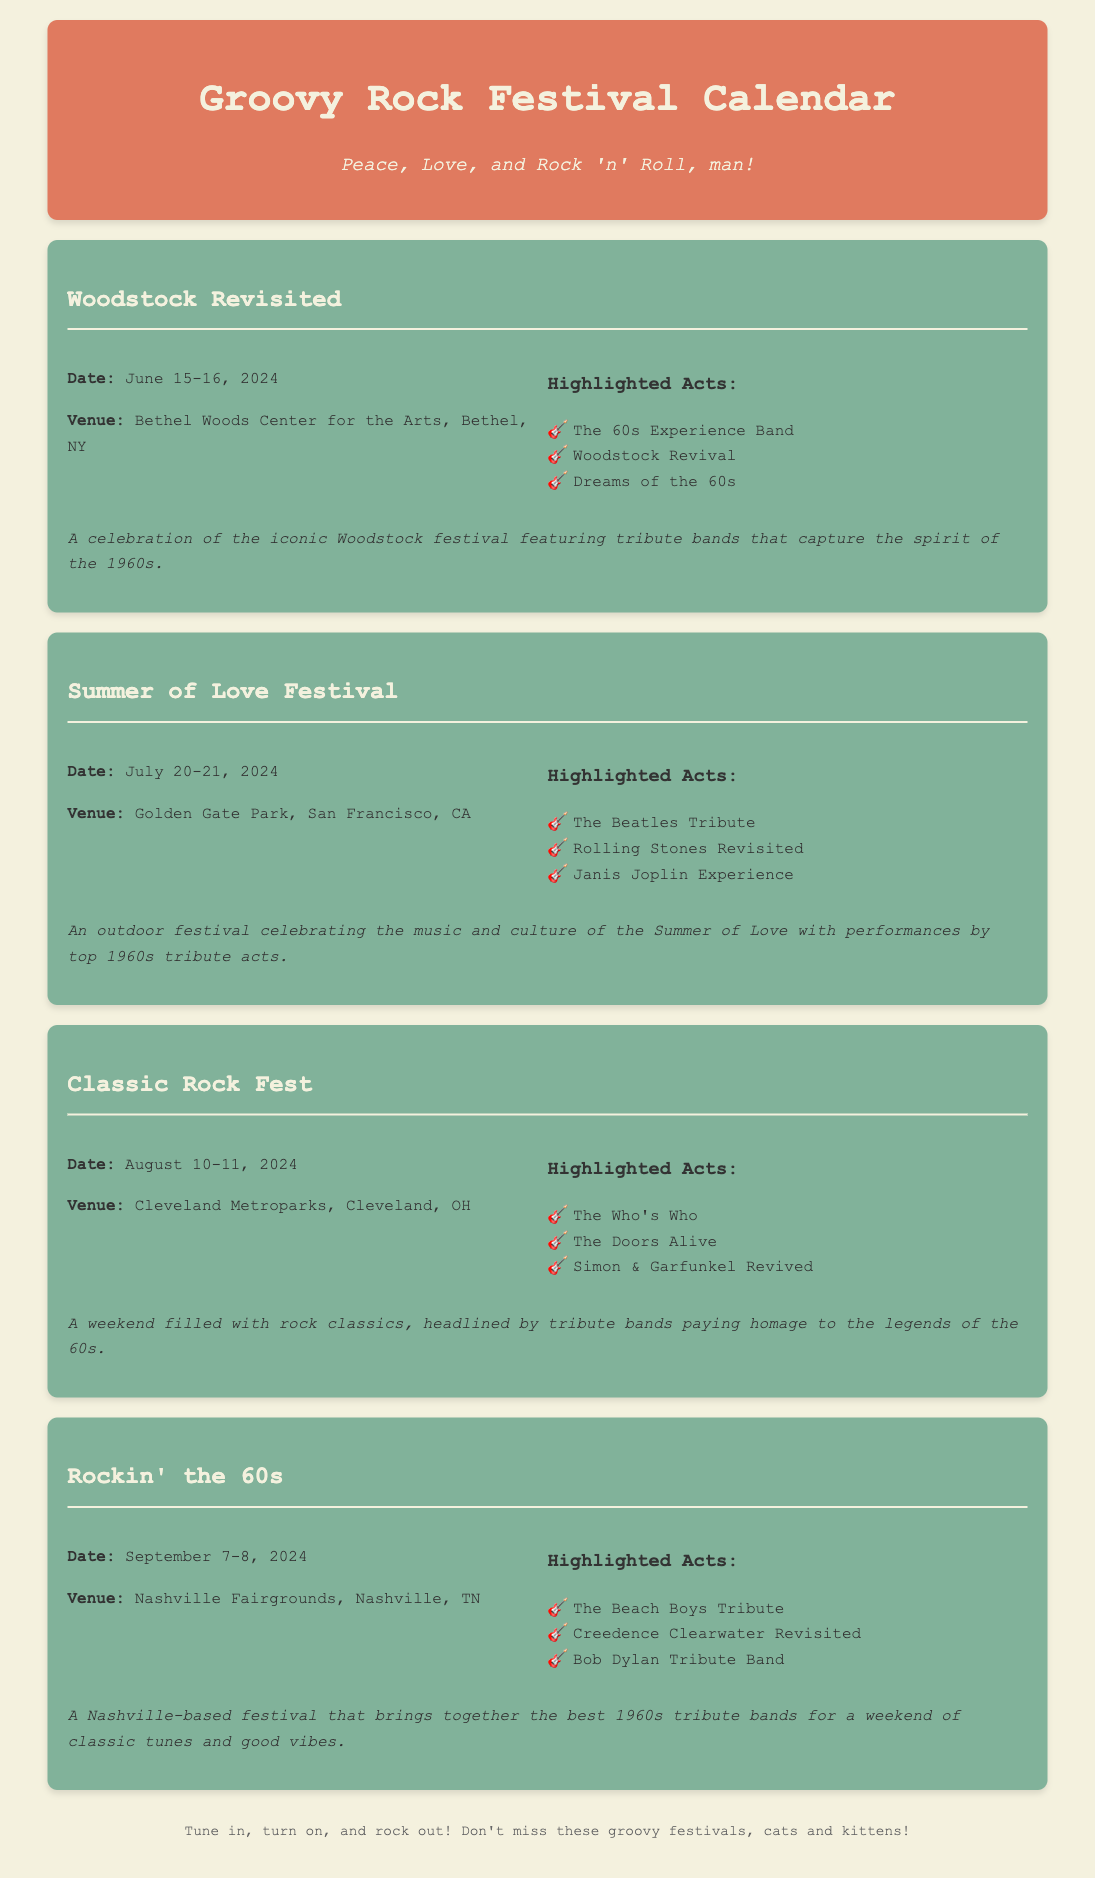What is the date of the Woodstock Revisited festival? The date of the Woodstock Revisited festival is mentioned as June 15-16, 2024.
Answer: June 15-16, 2024 Where is the Summer of Love Festival held? The specific venue for the Summer of Love Festival is Golden Gate Park, San Francisco, CA.
Answer: Golden Gate Park, San Francisco, CA Who are the highlighted acts for the Classic Rock Fest? The highlighted acts for the Classic Rock Fest are outlined in a list, including The Who's Who, The Doors Alive, and Simon & Garfunkel Revived.
Answer: The Who's Who, The Doors Alive, Simon & Garfunkel Revived What are the dates for the Rockin' the 60s festival? The dates for the Rockin' the 60s festival can be found in the festival details, specifically September 7-8, 2024.
Answer: September 7-8, 2024 Which festival features a tribute to Janis Joplin? The Summer of Love Festival showcases a tribute to Janis Joplin among its highlighted acts.
Answer: Summer of Love Festival How many festivals are listed in the document? The document lists a total of four festivals celebrating 1960s rock music.
Answer: Four What is the main theme of the Woodstock Revisited festival? The main theme of the Woodstock Revisited festival is a celebration of the iconic Woodstock festival and the spirit of the 1960s.
Answer: Celebration of the iconic Woodstock festival Which venue is shared by both the Woodstock Revisited and Classic Rock Fest? The page indicates that the Woodstock Revisited takes place at Bethel Woods Center for the Arts, while Classic Rock Fest occurs in Cleveland, Ohio; hence, no venue is shared.
Answer: No shared venue What is a common element among all festivals listed? A common element among all festivals listed is the presence of 1960s tribute bands performing classic rock music.
Answer: 1960s tribute bands 